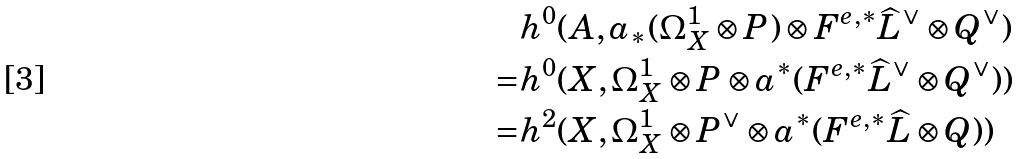Convert formula to latex. <formula><loc_0><loc_0><loc_500><loc_500>& h ^ { 0 } ( A , a _ { * } ( \Omega _ { X } ^ { 1 } \otimes P ) \otimes F ^ { e , * } \widehat { L } ^ { \vee } \otimes Q ^ { \vee } ) \\ = & h ^ { 0 } ( X , \Omega _ { X } ^ { 1 } \otimes P \otimes a ^ { * } ( F ^ { e , * } \widehat { L } ^ { \vee } \otimes Q ^ { \vee } ) ) \\ = & h ^ { 2 } ( X , \Omega _ { X } ^ { 1 } \otimes P ^ { \vee } \otimes a ^ { * } ( F ^ { e , * } \widehat { L } \otimes Q ) )</formula> 